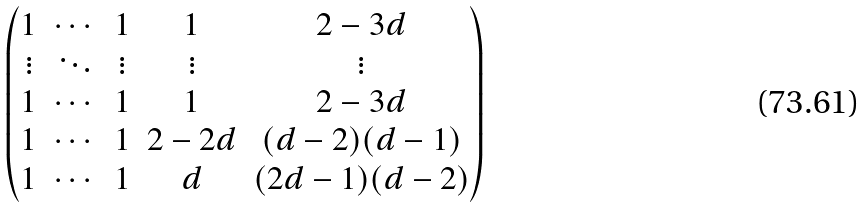Convert formula to latex. <formula><loc_0><loc_0><loc_500><loc_500>\begin{pmatrix} 1 & \cdots & 1 & 1 & 2 - 3 d \\ \vdots & \ddots & \vdots & \vdots & \vdots \\ 1 & \cdots & 1 & 1 & 2 - 3 d \\ 1 & \cdots & 1 & 2 - 2 d & ( d - 2 ) ( d - 1 ) \\ 1 & \cdots & 1 & d & ( 2 d - 1 ) ( d - 2 ) \end{pmatrix}</formula> 